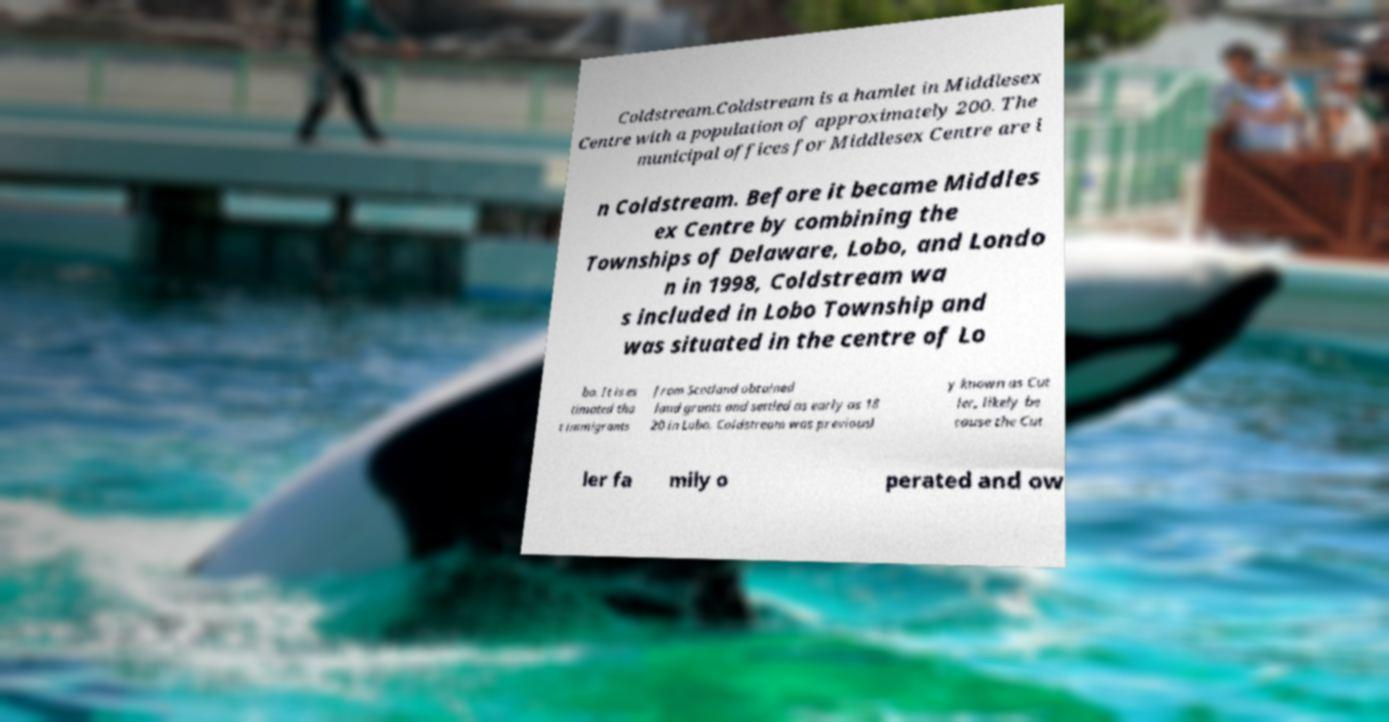Please read and relay the text visible in this image. What does it say? Coldstream.Coldstream is a hamlet in Middlesex Centre with a population of approximately 200. The municipal offices for Middlesex Centre are i n Coldstream. Before it became Middles ex Centre by combining the Townships of Delaware, Lobo, and Londo n in 1998, Coldstream wa s included in Lobo Township and was situated in the centre of Lo bo. It is es timated tha t immigrants from Scotland obtained land grants and settled as early as 18 20 in Lobo. Coldstream was previousl y known as Cut ler, likely be cause the Cut ler fa mily o perated and ow 